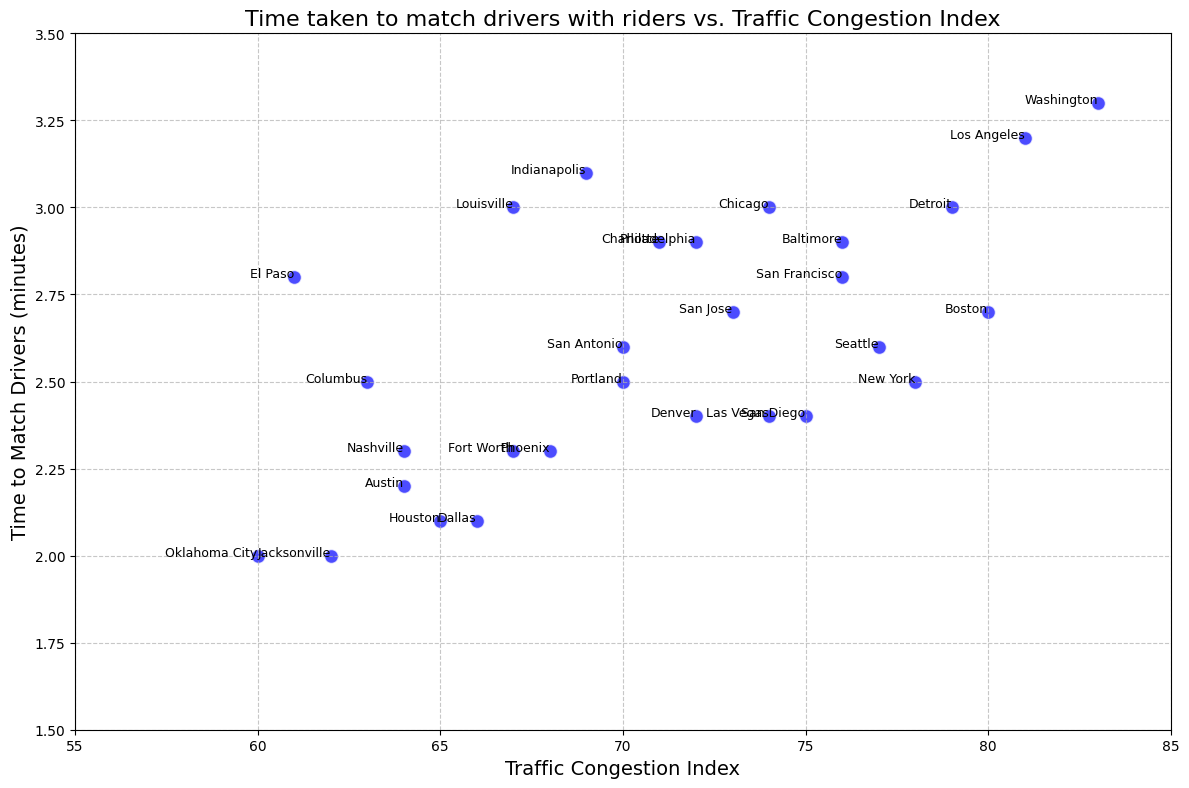Which urban area has the highest Traffic Congestion Index, and what is the corresponding Time to Match? To find the urban area with the highest Traffic Congestion Index, we look for the point with the highest x-axis value, which is 83. The corresponding y-axis value at this point is 3.3 minutes (Washington).
Answer: Washington, 3.3 minutes Which urban area has the lowest Time to Match, and what is the corresponding Traffic Congestion Index? To find the urban area with the lowest Time to Match, we look for the point with the lowest y-axis value, which is 2.0 minutes. The corresponding x-axis values at these points are 62 and 60, for Jacksonville and Oklahoma City, respectively.
Answer: Jacksonville, Oklahoma City; 62, 60 Is there a general trend between Traffic Congestion Index and Time to Match? By observing the scatter plot, a positive correlation can be detected where higher Traffic Congestion Index values tend to have higher Time to Match values, though there are exceptions.
Answer: Positive correlation What's the difference in Time to Match between the urban areas with the highest and lowest Traffic Congestion Index? The highest Traffic Congestion Index is 83 (Washington, 3.3 minutes) and the lowest is 60 (Oklahoma City, 2.0 minutes). The difference in Time to Match is 3.3 - 2.0 = 1.3 minutes.
Answer: 1.3 minutes Which urban area has the highest Time to Match with a Traffic Congestion Index below 70? Filtering the points with a Traffic Congestion Index below 70, the highest y-value for Time to Match is 3.1 minutes for Indianapolis.
Answer: Indianapolis Are there any urban areas with a Time to Match greater than 3.0 minutes but with a Traffic Congestion Index lower than 75? Observing the scatter points above the y-value of 3.0 minutes, only Chicago (74), Los Angeles (81), Washington (83), and Detroit (79) have Time to Match greater than 3.0 minutes, so only Chicago qualifies as having a Traffic Congestion Index below 75.
Answer: Chicago What are the average values for Time to Match and Traffic Congestion Index? Calculate the average Time to Match by summing up all the Time to Match values and dividing by the number of urban areas. Similarly, for Traffic Congestion Index, sum the values and divide by the number of urban areas: (2.5+3.2+2.8...)/28, (78+81+76...)/28. Averaging both: 2.63 and 71.3.
Answer: 2.63 minutes, 71.3 